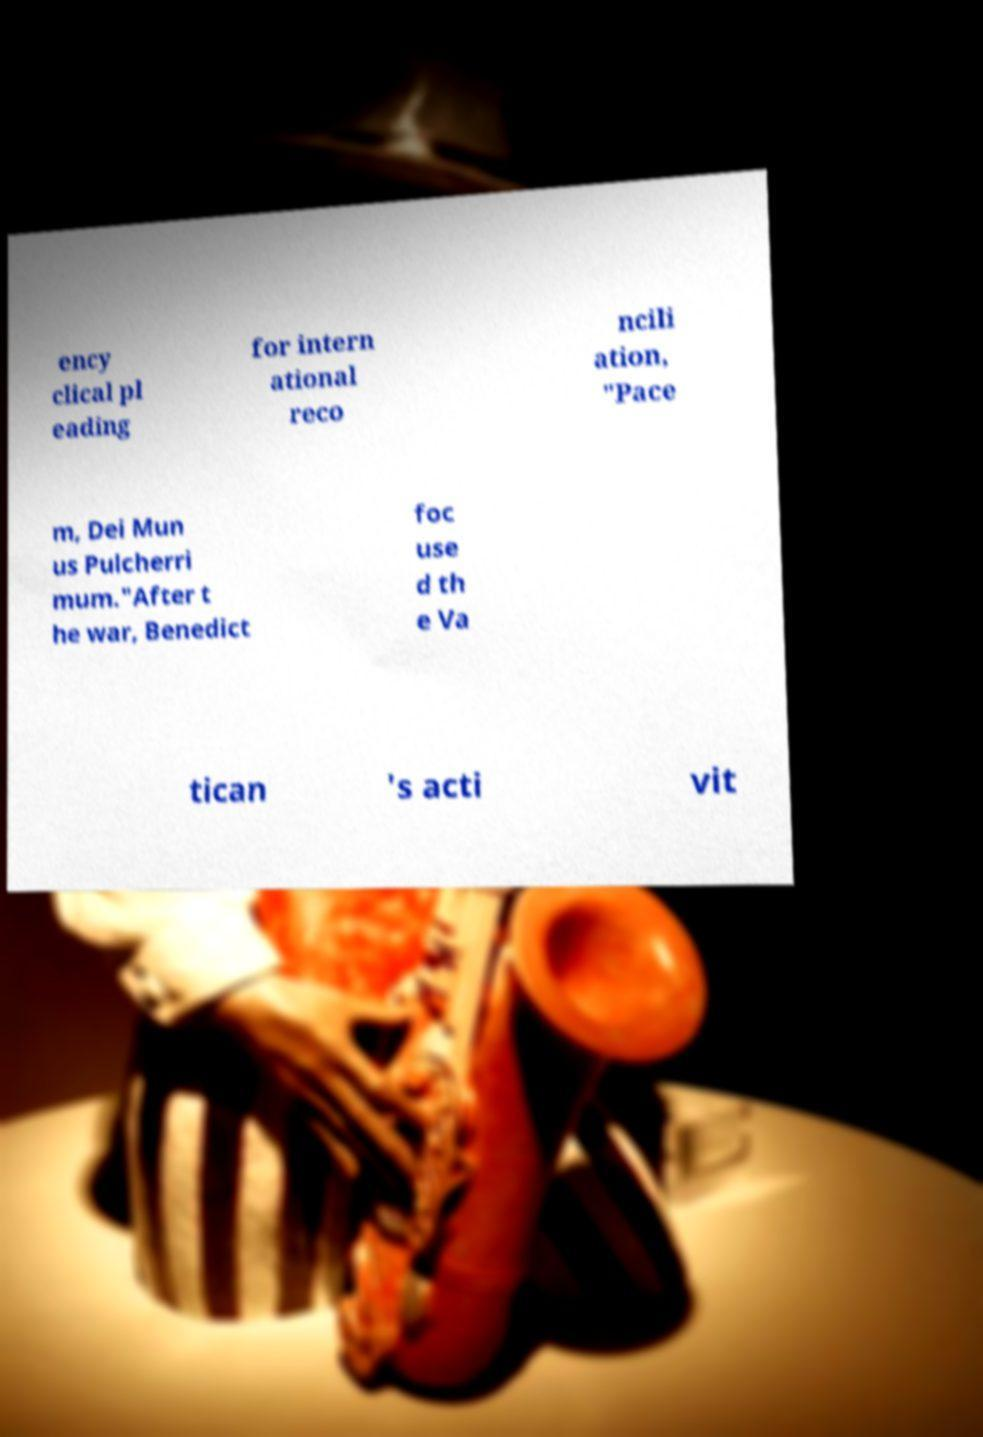What messages or text are displayed in this image? I need them in a readable, typed format. ency clical pl eading for intern ational reco ncili ation, "Pace m, Dei Mun us Pulcherri mum."After t he war, Benedict foc use d th e Va tican 's acti vit 